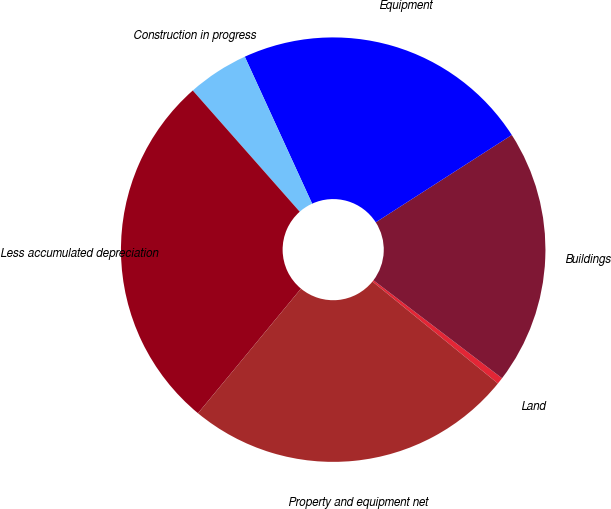Convert chart to OTSL. <chart><loc_0><loc_0><loc_500><loc_500><pie_chart><fcel>Land<fcel>Buildings<fcel>Equipment<fcel>Construction in progress<fcel>Less accumulated depreciation<fcel>Property and equipment net<nl><fcel>0.5%<fcel>19.44%<fcel>22.75%<fcel>4.67%<fcel>27.5%<fcel>25.13%<nl></chart> 